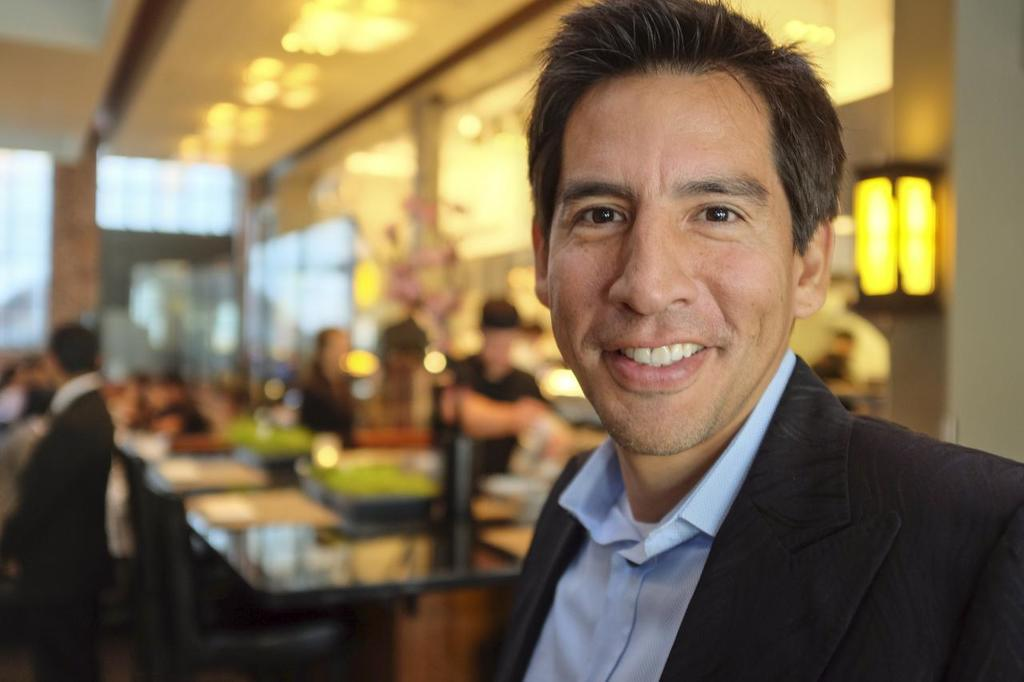What is the person in the image wearing? The person is wearing a suit. Can you describe the people in the background of the image? There are people standing in the background of the image. What else can be seen in the background of the image? There are tables visible in the background of the image. How is the background of the image depicted? The background is blurred. What type of feast is the person in the image participating in? There is no feast present in the image; it only shows a person standing in a suit with a blurred background. Can you describe how the person in the image is touching the tables in the background? The person in the image is not touching any tables; they are standing apart from the tables visible in the background. 